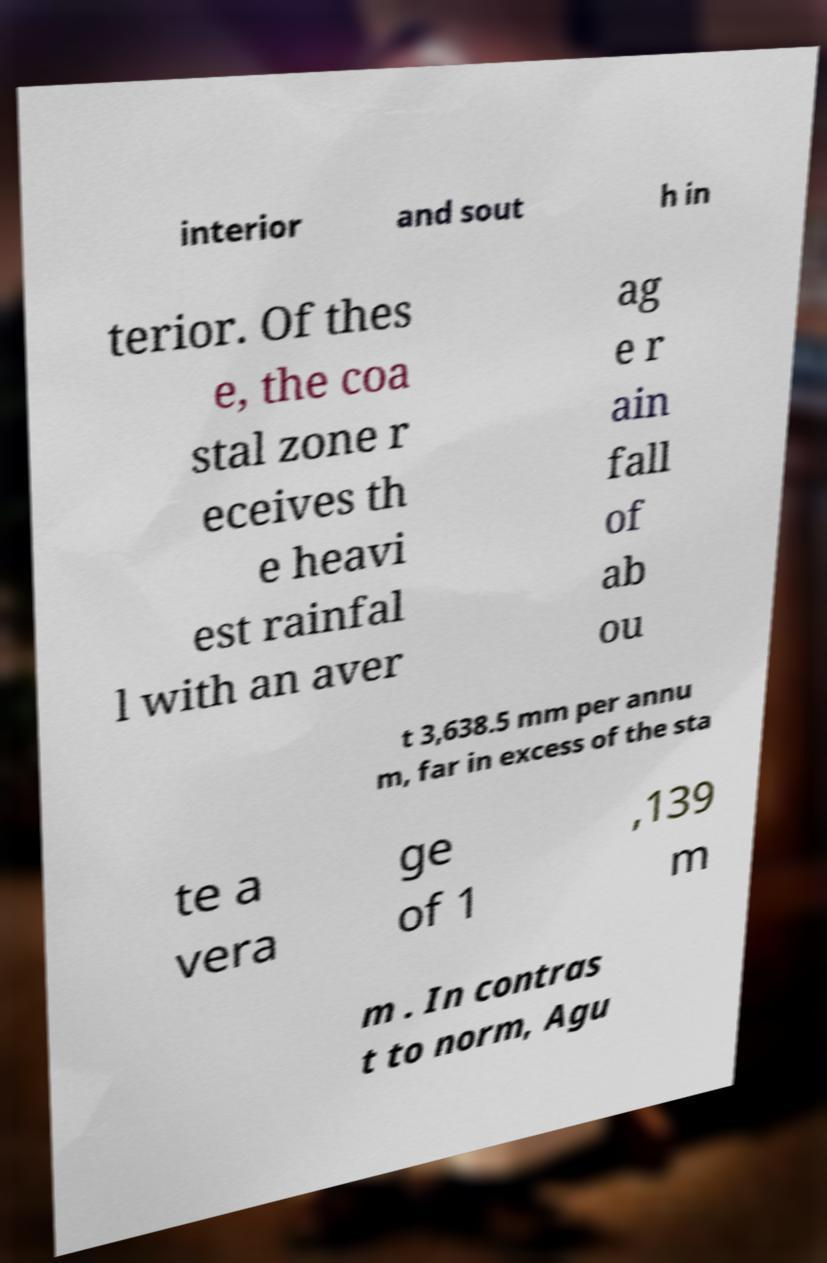What messages or text are displayed in this image? I need them in a readable, typed format. interior and sout h in terior. Of thes e, the coa stal zone r eceives th e heavi est rainfal l with an aver ag e r ain fall of ab ou t 3,638.5 mm per annu m, far in excess of the sta te a vera ge of 1 ,139 m m . In contras t to norm, Agu 